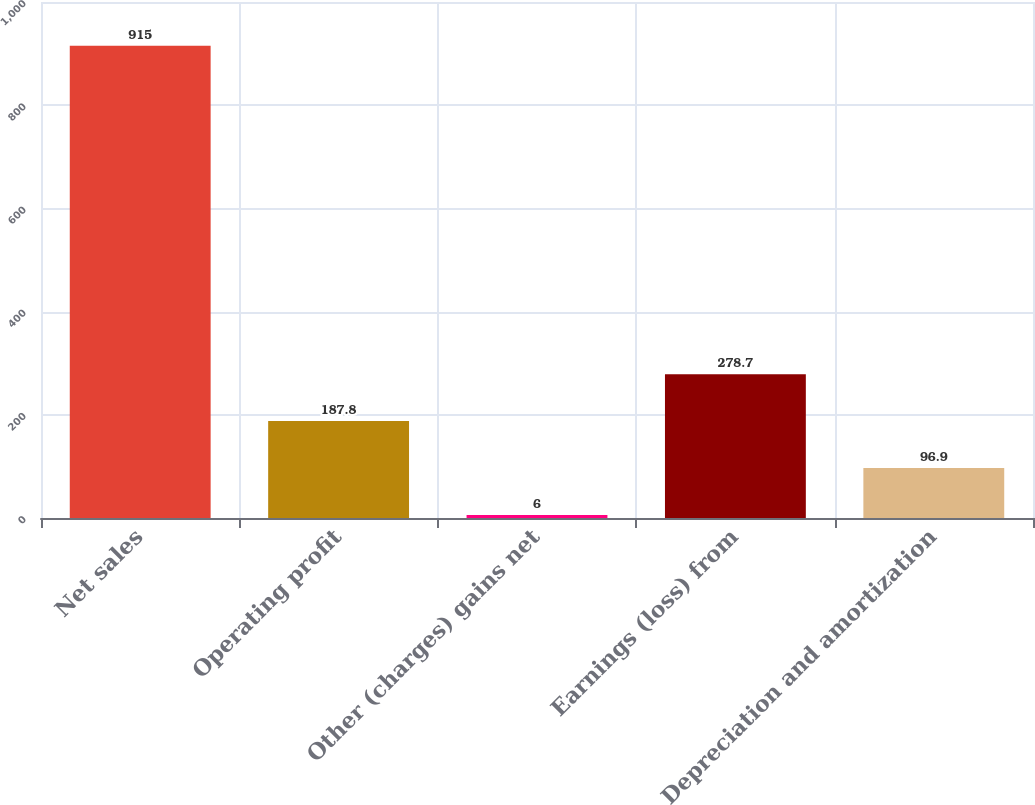Convert chart. <chart><loc_0><loc_0><loc_500><loc_500><bar_chart><fcel>Net sales<fcel>Operating profit<fcel>Other (charges) gains net<fcel>Earnings (loss) from<fcel>Depreciation and amortization<nl><fcel>915<fcel>187.8<fcel>6<fcel>278.7<fcel>96.9<nl></chart> 